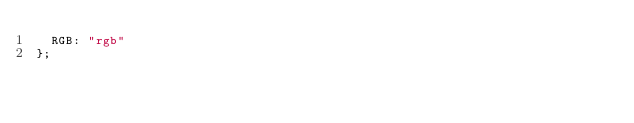Convert code to text. <code><loc_0><loc_0><loc_500><loc_500><_JavaScript_>	RGB: "rgb"
};</code> 